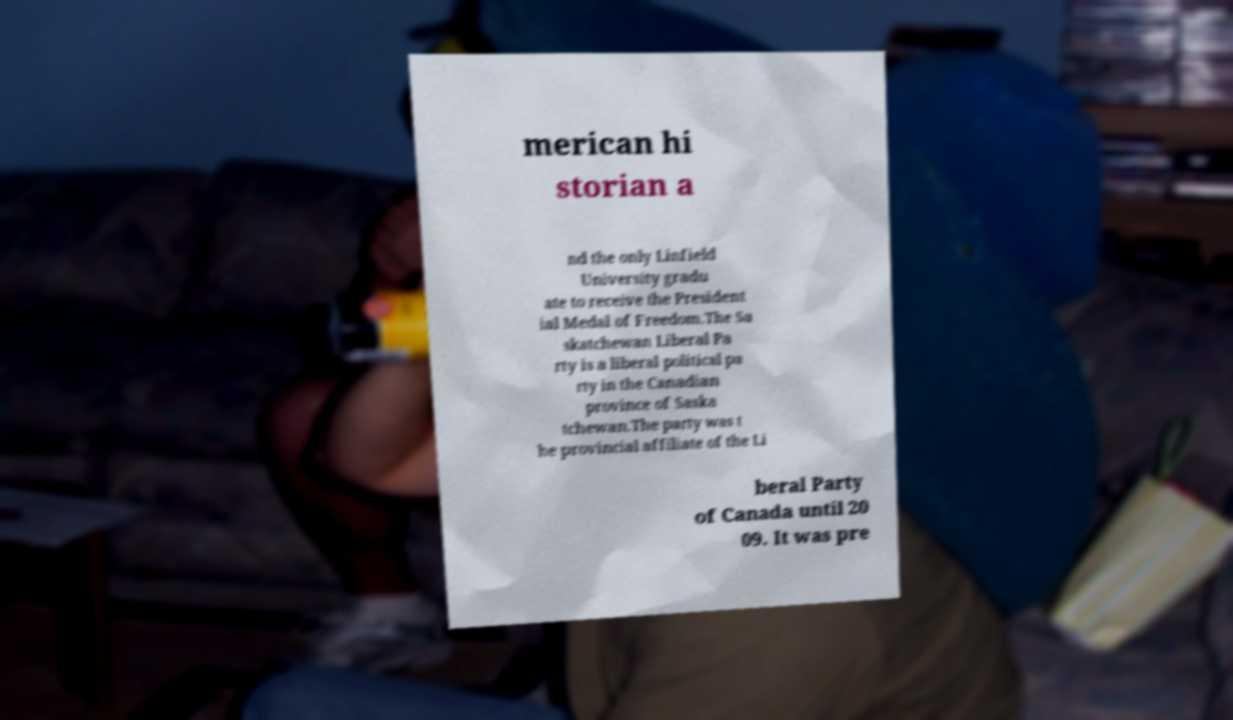Can you read and provide the text displayed in the image?This photo seems to have some interesting text. Can you extract and type it out for me? merican hi storian a nd the only Linfield University gradu ate to receive the President ial Medal of Freedom.The Sa skatchewan Liberal Pa rty is a liberal political pa rty in the Canadian province of Saska tchewan.The party was t he provincial affiliate of the Li beral Party of Canada until 20 09. It was pre 